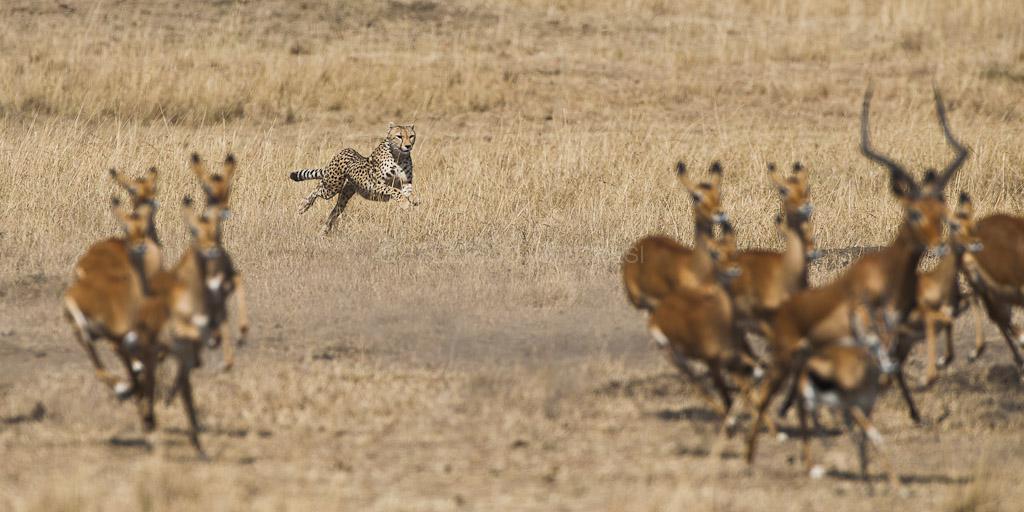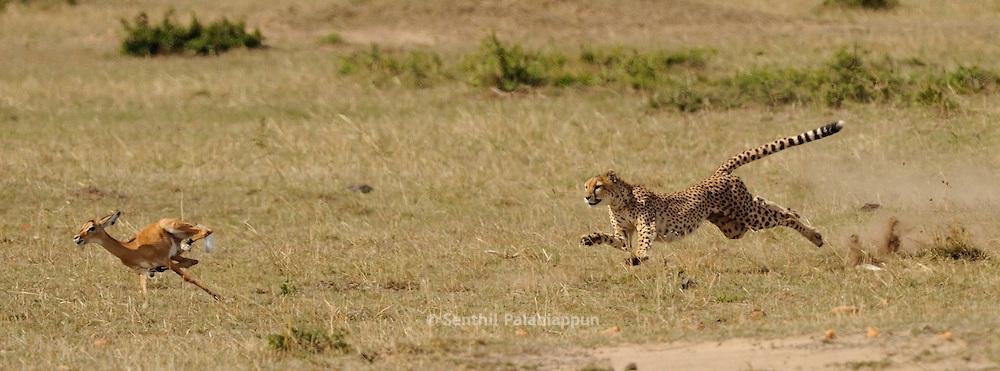The first image is the image on the left, the second image is the image on the right. Assess this claim about the two images: "Multiple cheetahs are bounding leftward to attack a gazelle in one image.". Correct or not? Answer yes or no. No. 